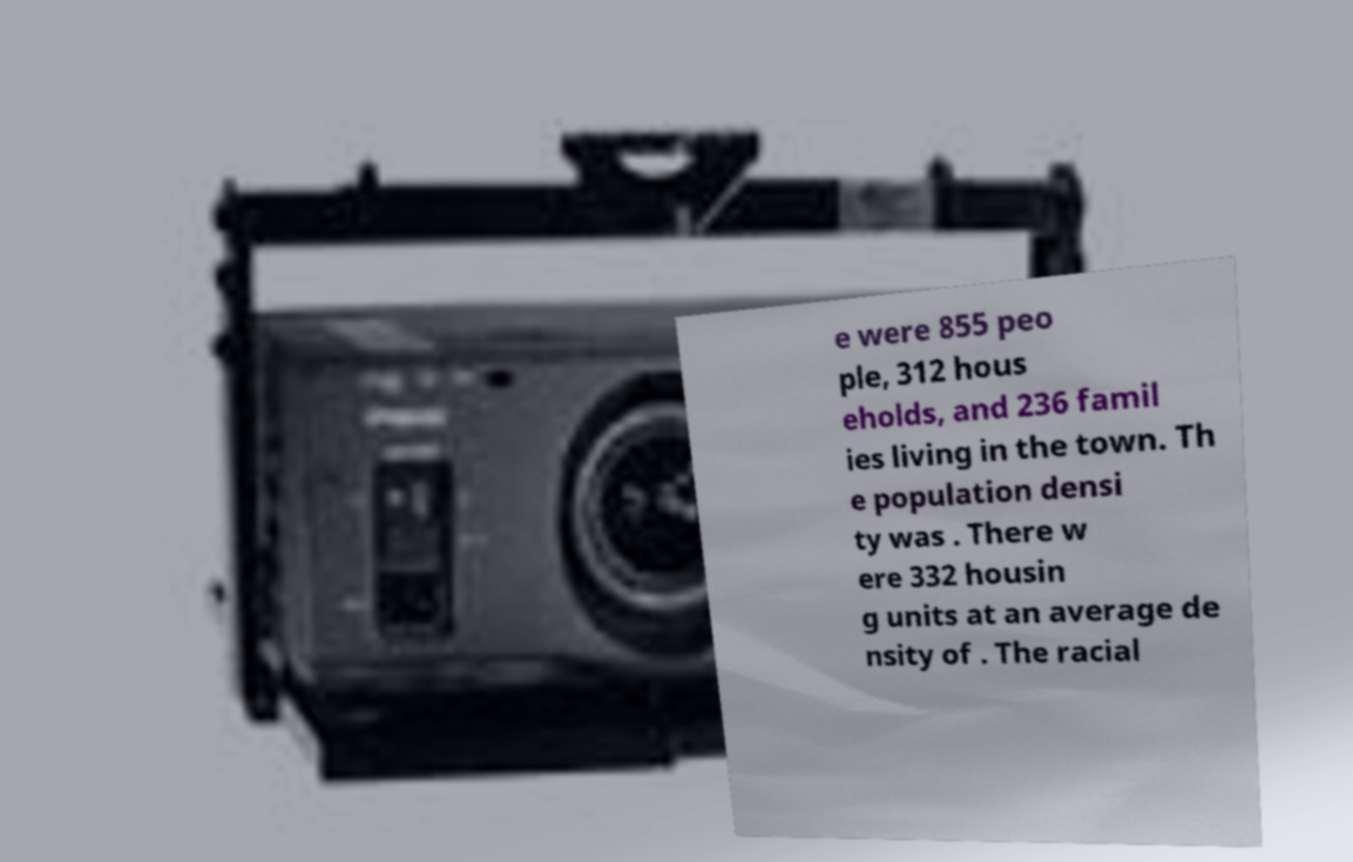Please identify and transcribe the text found in this image. e were 855 peo ple, 312 hous eholds, and 236 famil ies living in the town. Th e population densi ty was . There w ere 332 housin g units at an average de nsity of . The racial 